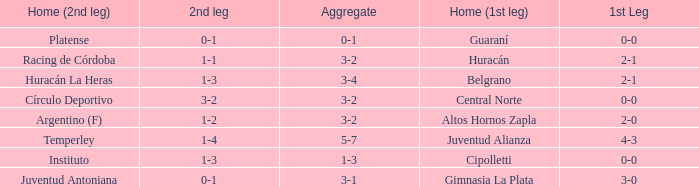Can you give me this table as a dict? {'header': ['Home (2nd leg)', '2nd leg', 'Aggregate', 'Home (1st leg)', '1st Leg'], 'rows': [['Platense', '0-1', '0-1', 'Guaraní', '0-0'], ['Racing de Córdoba', '1-1', '3-2', 'Huracán', '2-1'], ['Huracán La Heras', '1-3', '3-4', 'Belgrano', '2-1'], ['Círculo Deportivo', '3-2', '3-2', 'Central Norte', '0-0'], ['Argentino (F)', '1-2', '3-2', 'Altos Hornos Zapla', '2-0'], ['Temperley', '1-4', '5-7', 'Juventud Alianza', '4-3'], ['Instituto', '1-3', '1-3', 'Cipolletti', '0-0'], ['Juventud Antoniana', '0-1', '3-1', 'Gimnasia La Plata', '3-0']]} Who played at home for the 2nd leg with a score of 1-2? Argentino (F). 